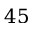<formula> <loc_0><loc_0><loc_500><loc_500>4 5</formula> 